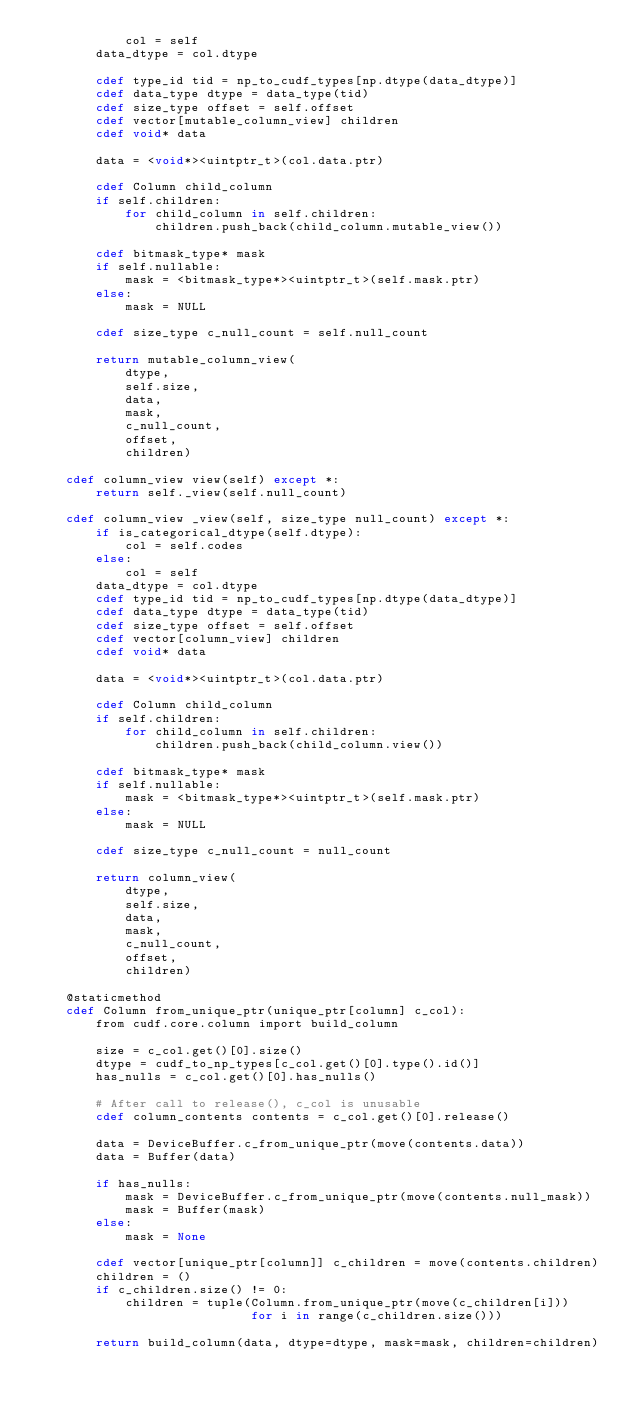<code> <loc_0><loc_0><loc_500><loc_500><_Cython_>            col = self
        data_dtype = col.dtype

        cdef type_id tid = np_to_cudf_types[np.dtype(data_dtype)]
        cdef data_type dtype = data_type(tid)
        cdef size_type offset = self.offset
        cdef vector[mutable_column_view] children
        cdef void* data

        data = <void*><uintptr_t>(col.data.ptr)

        cdef Column child_column
        if self.children:
            for child_column in self.children:
                children.push_back(child_column.mutable_view())

        cdef bitmask_type* mask
        if self.nullable:
            mask = <bitmask_type*><uintptr_t>(self.mask.ptr)
        else:
            mask = NULL

        cdef size_type c_null_count = self.null_count

        return mutable_column_view(
            dtype,
            self.size,
            data,
            mask,
            c_null_count,
            offset,
            children)

    cdef column_view view(self) except *:
        return self._view(self.null_count)

    cdef column_view _view(self, size_type null_count) except *:
        if is_categorical_dtype(self.dtype):
            col = self.codes
        else:
            col = self
        data_dtype = col.dtype
        cdef type_id tid = np_to_cudf_types[np.dtype(data_dtype)]
        cdef data_type dtype = data_type(tid)
        cdef size_type offset = self.offset
        cdef vector[column_view] children
        cdef void* data

        data = <void*><uintptr_t>(col.data.ptr)

        cdef Column child_column
        if self.children:
            for child_column in self.children:
                children.push_back(child_column.view())

        cdef bitmask_type* mask
        if self.nullable:
            mask = <bitmask_type*><uintptr_t>(self.mask.ptr)
        else:
            mask = NULL

        cdef size_type c_null_count = null_count

        return column_view(
            dtype,
            self.size,
            data,
            mask,
            c_null_count,
            offset,
            children)

    @staticmethod
    cdef Column from_unique_ptr(unique_ptr[column] c_col):
        from cudf.core.column import build_column

        size = c_col.get()[0].size()
        dtype = cudf_to_np_types[c_col.get()[0].type().id()]
        has_nulls = c_col.get()[0].has_nulls()

        # After call to release(), c_col is unusable
        cdef column_contents contents = c_col.get()[0].release()

        data = DeviceBuffer.c_from_unique_ptr(move(contents.data))
        data = Buffer(data)

        if has_nulls:
            mask = DeviceBuffer.c_from_unique_ptr(move(contents.null_mask))
            mask = Buffer(mask)
        else:
            mask = None

        cdef vector[unique_ptr[column]] c_children = move(contents.children)
        children = ()
        if c_children.size() != 0:
            children = tuple(Column.from_unique_ptr(move(c_children[i]))
                             for i in range(c_children.size()))

        return build_column(data, dtype=dtype, mask=mask, children=children)
</code> 